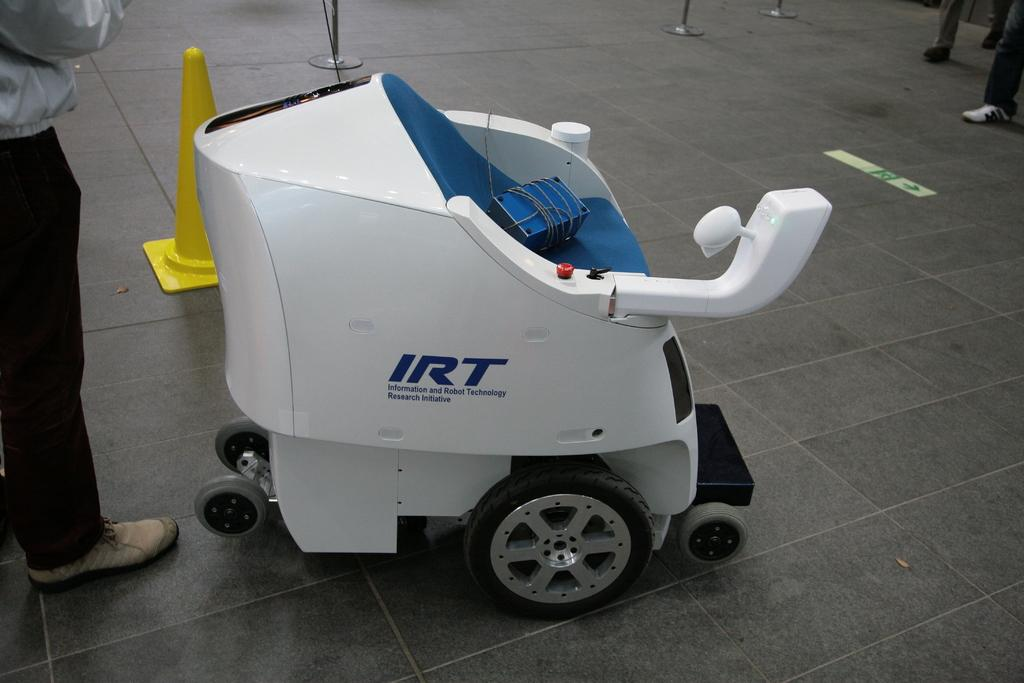<image>
Create a compact narrative representing the image presented. A robot from the Information and Robot Technology Research Initiative is on display. 